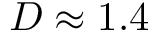Convert formula to latex. <formula><loc_0><loc_0><loc_500><loc_500>D \approx 1 . 4</formula> 